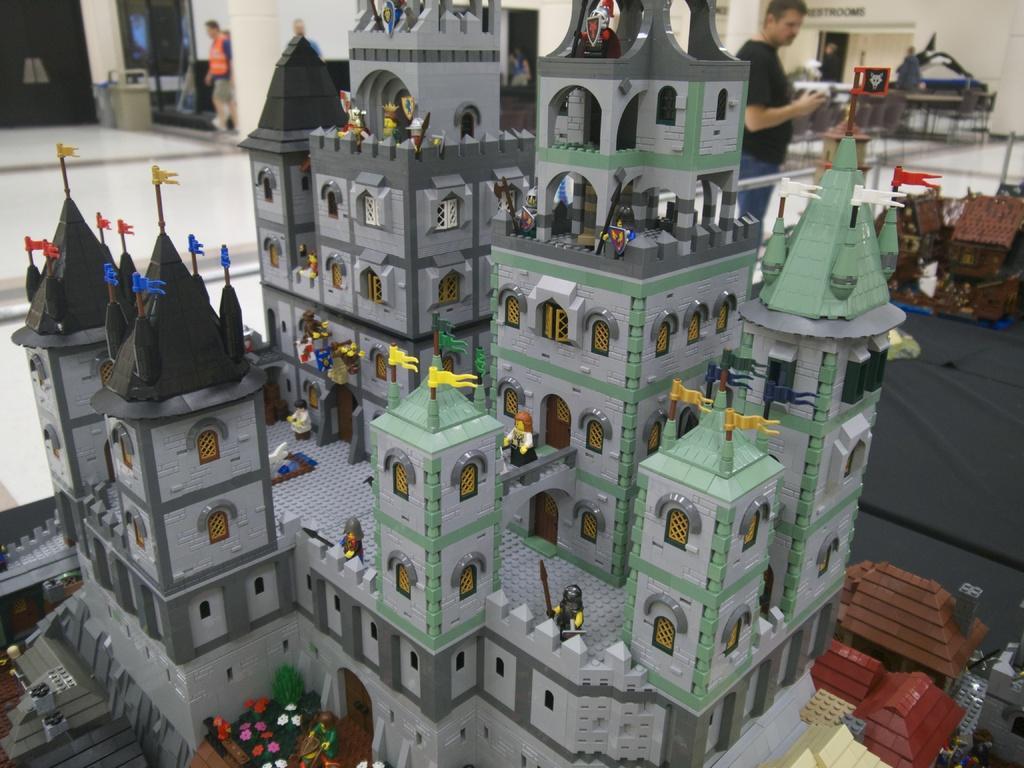Could you give a brief overview of what you see in this image? In this picture there are miniatures of buildings on the tables. At the back there are two person standing and there is a person walking and there are tables and there is a dustbin and there is a text on the wall. At the bottom there is a floor. 